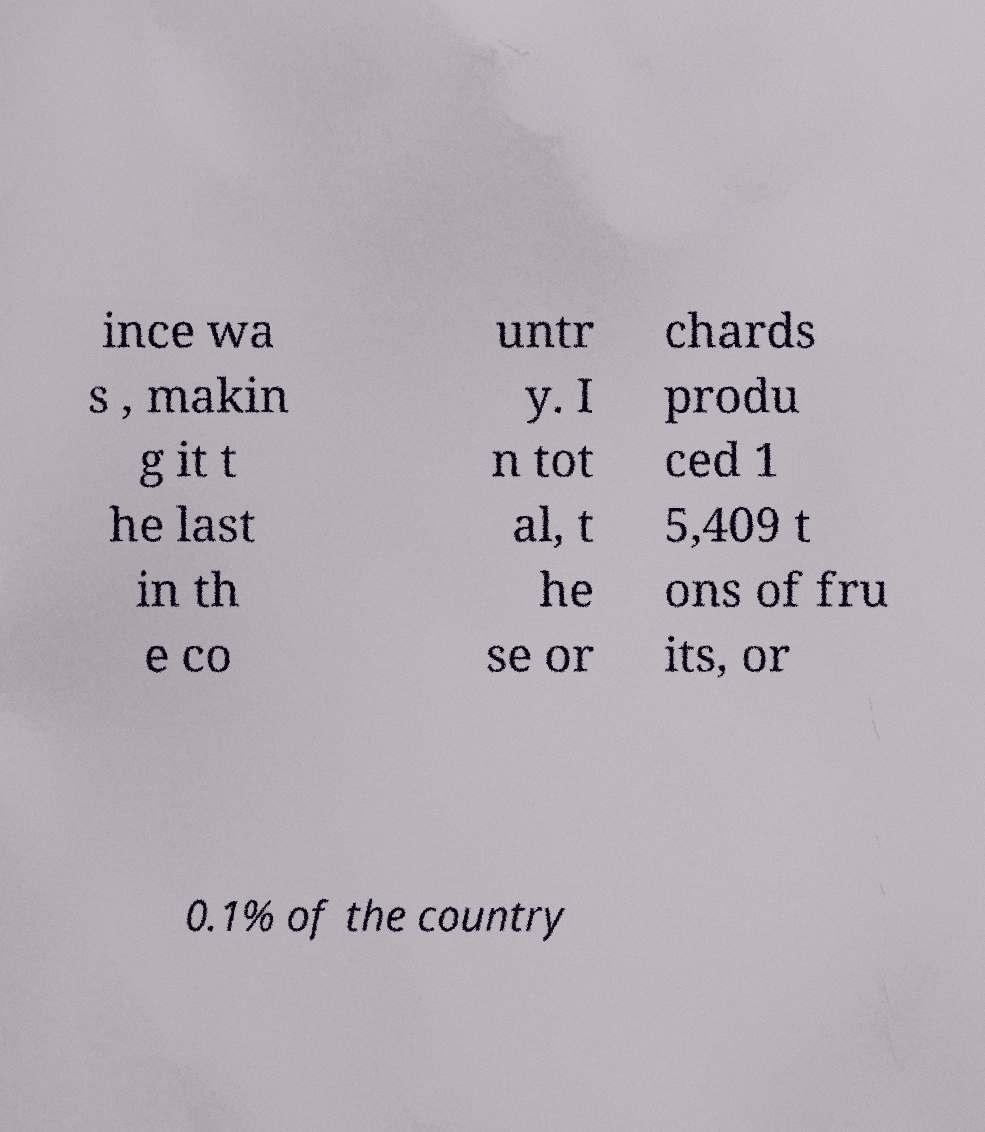Could you extract and type out the text from this image? ince wa s , makin g it t he last in th e co untr y. I n tot al, t he se or chards produ ced 1 5,409 t ons of fru its, or 0.1% of the country 